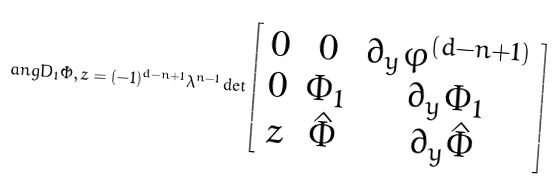Convert formula to latex. <formula><loc_0><loc_0><loc_500><loc_500>\ a n g { { D } _ { 1 } \tilde { \Phi } , z } = ( - 1 ) ^ { d - n + 1 } \lambda ^ { n - 1 } \det \left [ \begin{array} { c c c } 0 & 0 & \partial _ { y } \varphi ^ { ( d - n + 1 ) } \\ 0 & \Phi _ { 1 } & \partial _ { y } \Phi _ { 1 } \\ z & \hat { \Phi } & \partial _ { y } \hat { \Phi } \end{array} \right ]</formula> 